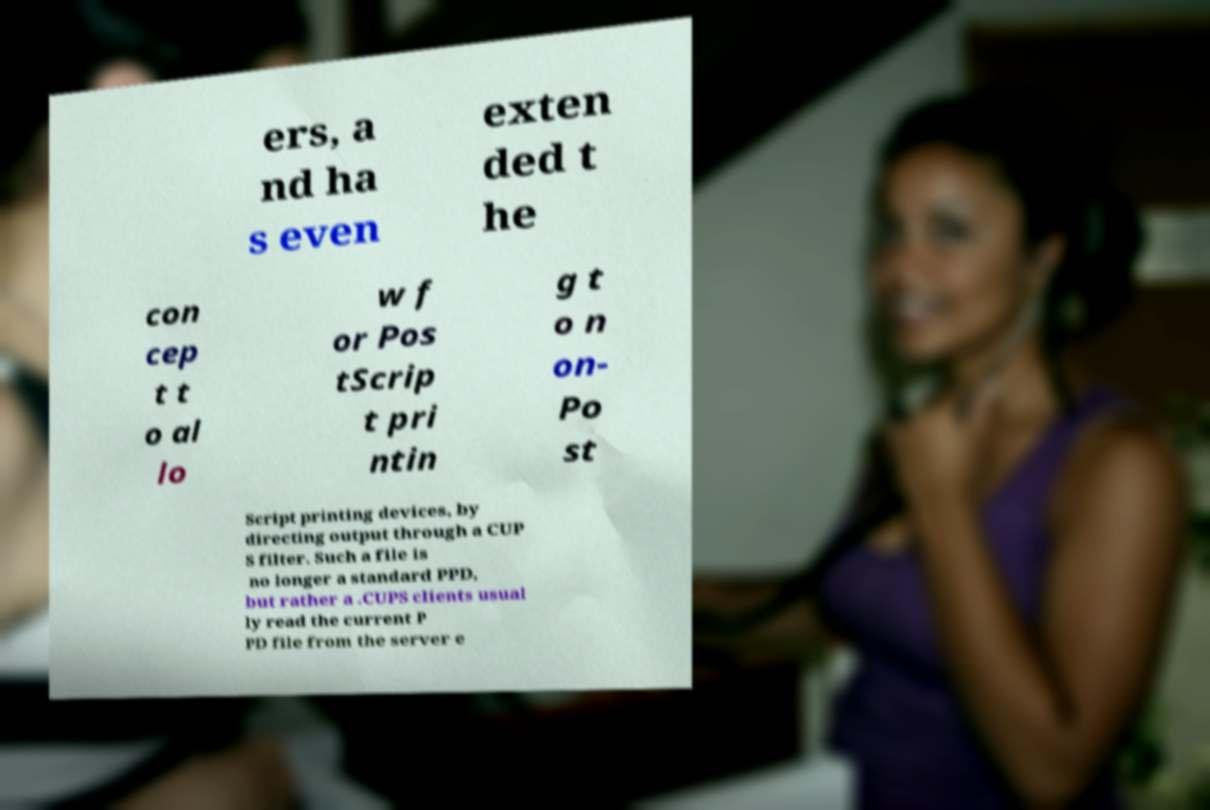I need the written content from this picture converted into text. Can you do that? ers, a nd ha s even exten ded t he con cep t t o al lo w f or Pos tScrip t pri ntin g t o n on- Po st Script printing devices, by directing output through a CUP S filter. Such a file is no longer a standard PPD, but rather a .CUPS clients usual ly read the current P PD file from the server e 